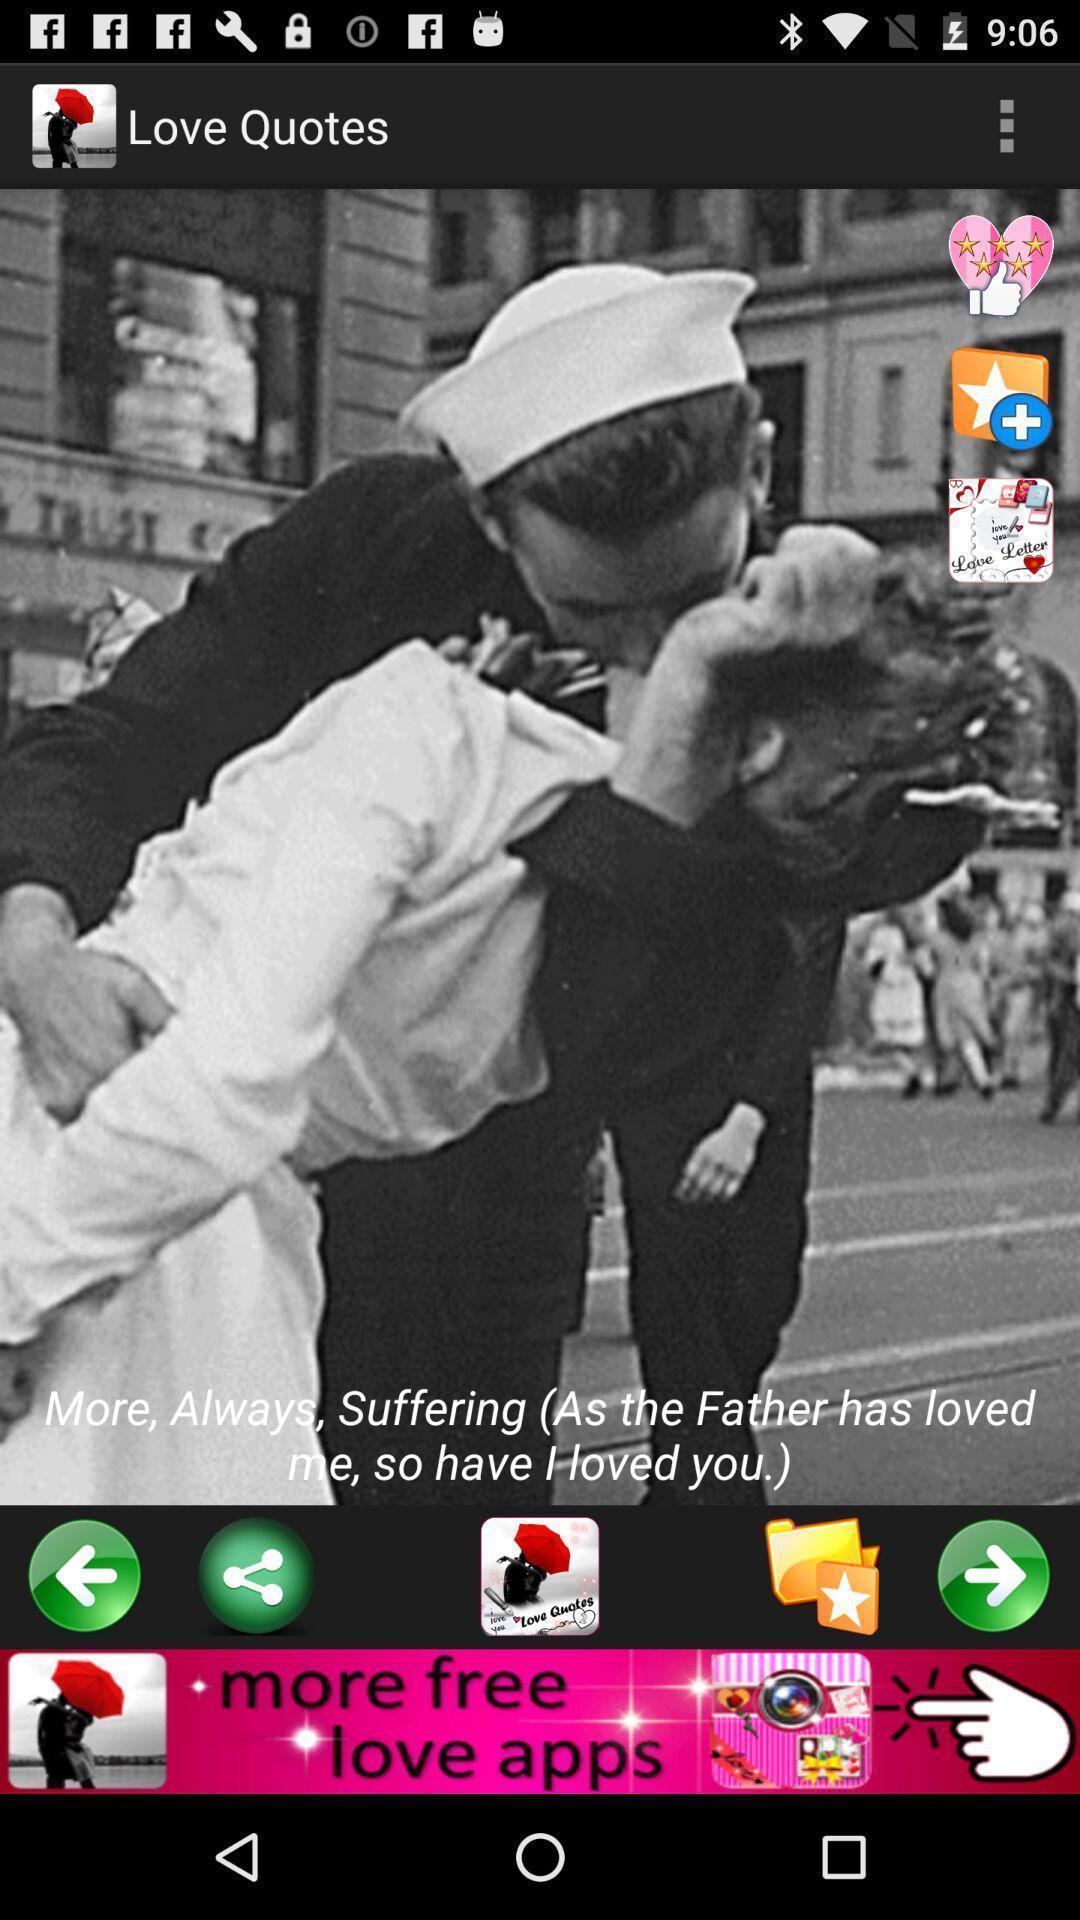Provide a description of this screenshot. Page displaying image with quotation. 